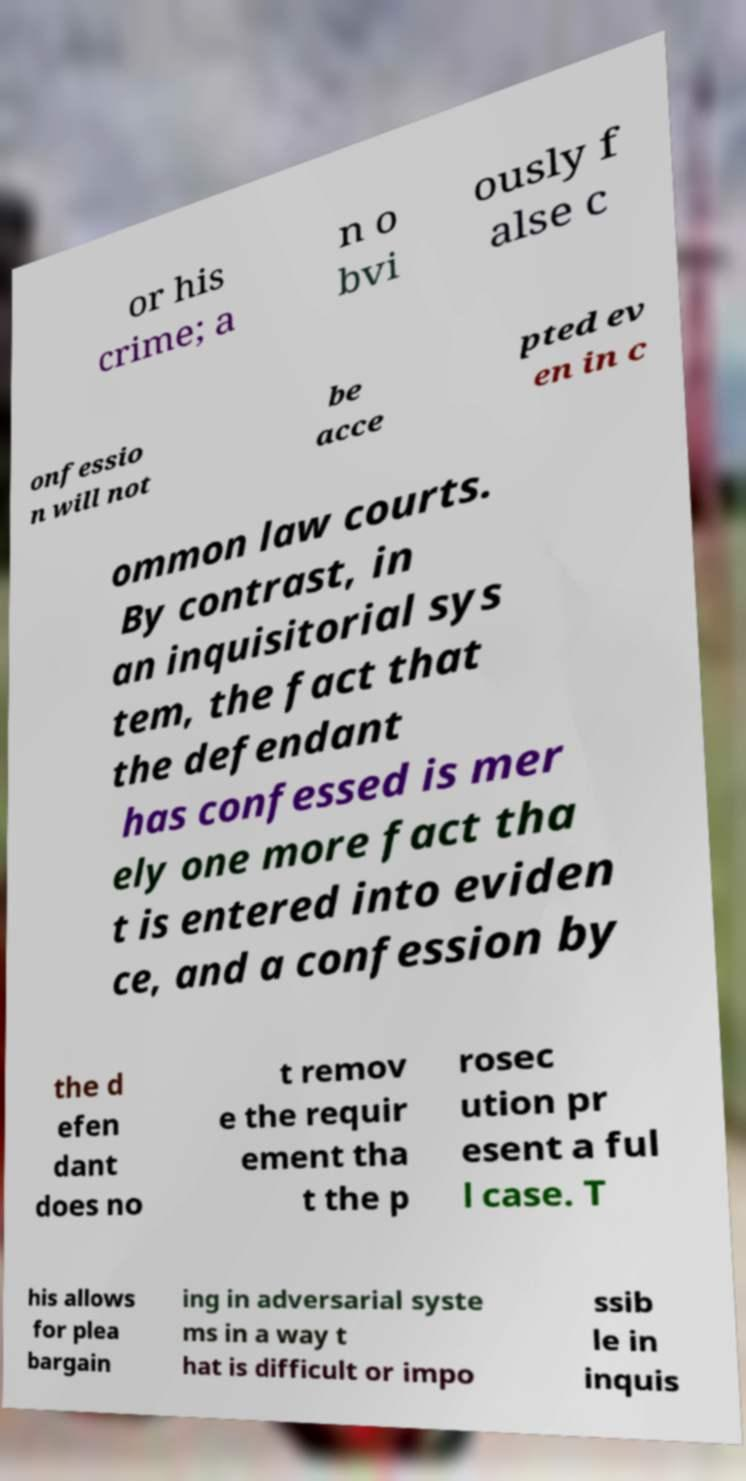What messages or text are displayed in this image? I need them in a readable, typed format. or his crime; a n o bvi ously f alse c onfessio n will not be acce pted ev en in c ommon law courts. By contrast, in an inquisitorial sys tem, the fact that the defendant has confessed is mer ely one more fact tha t is entered into eviden ce, and a confession by the d efen dant does no t remov e the requir ement tha t the p rosec ution pr esent a ful l case. T his allows for plea bargain ing in adversarial syste ms in a way t hat is difficult or impo ssib le in inquis 